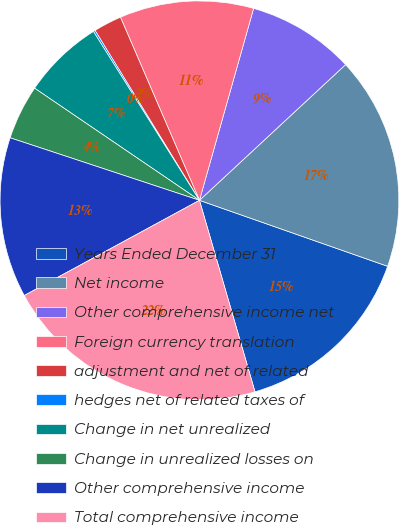Convert chart to OTSL. <chart><loc_0><loc_0><loc_500><loc_500><pie_chart><fcel>Years Ended December 31<fcel>Net income<fcel>Other comprehensive income net<fcel>Foreign currency translation<fcel>adjustment and net of related<fcel>hedges net of related taxes of<fcel>Change in net unrealized<fcel>Change in unrealized losses on<fcel>Other comprehensive income<fcel>Total comprehensive income<nl><fcel>15.14%<fcel>17.28%<fcel>8.71%<fcel>10.86%<fcel>2.29%<fcel>0.15%<fcel>6.57%<fcel>4.43%<fcel>13.0%<fcel>21.57%<nl></chart> 